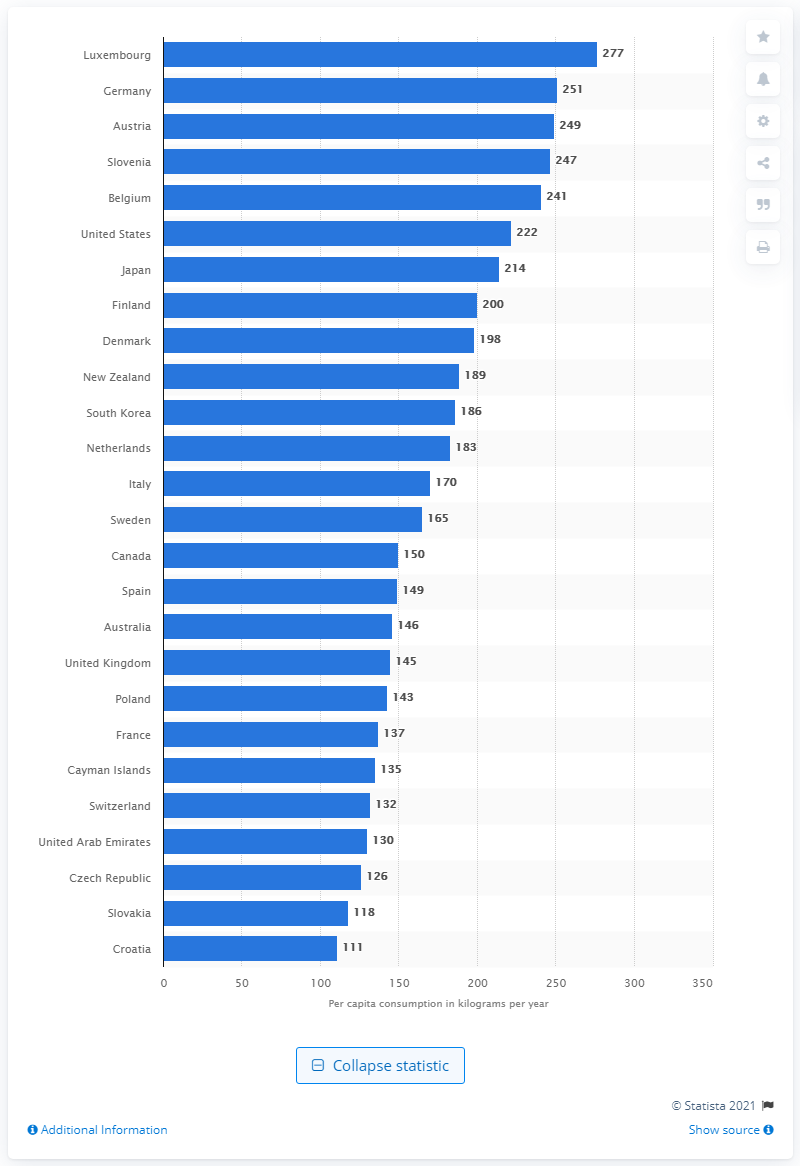Draw attention to some important aspects in this diagram. In 2015, Luxembourg was the country that consumed the largest amount of paper per capita, when measured as a percentage of its gross domestic product (GDP). 